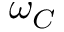Convert formula to latex. <formula><loc_0><loc_0><loc_500><loc_500>\omega _ { C }</formula> 